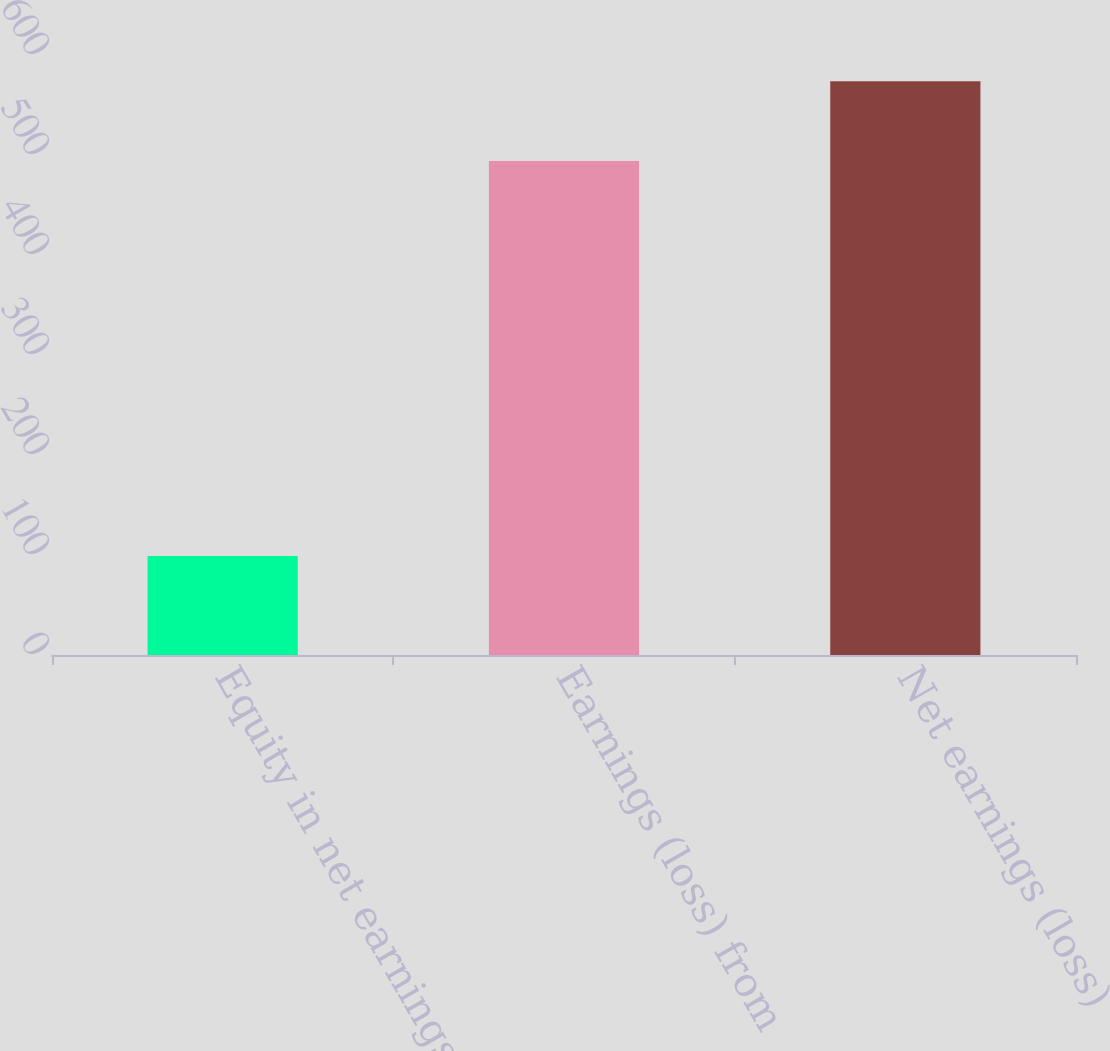<chart> <loc_0><loc_0><loc_500><loc_500><bar_chart><fcel>Equity in net earnings (loss)<fcel>Earnings (loss) from<fcel>Net earnings (loss)<nl><fcel>99<fcel>494<fcel>573.8<nl></chart> 